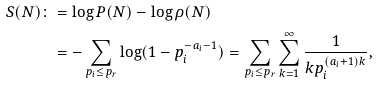Convert formula to latex. <formula><loc_0><loc_0><loc_500><loc_500>S ( N ) \colon & = \log P ( N ) - \log \rho ( N ) \\ & = - \sum _ { p _ { i } \leq p _ { r } } \log ( 1 - p _ { i } ^ { - a _ { i } - 1 } ) = \sum _ { p _ { i } \leq p _ { r } } \sum _ { k = 1 } ^ { \infty } \frac { 1 } { k p _ { i } ^ { ( a _ { i } + 1 ) k } } ,</formula> 